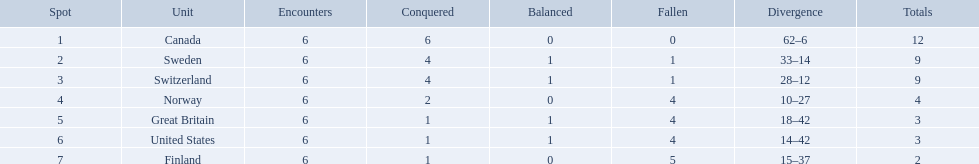What are all the teams? Canada, Sweden, Switzerland, Norway, Great Britain, United States, Finland. What were their points? 12, 9, 9, 4, 3, 3, 2. What about just switzerland and great britain? 9, 3. Now, which of those teams scored higher? Switzerland. 